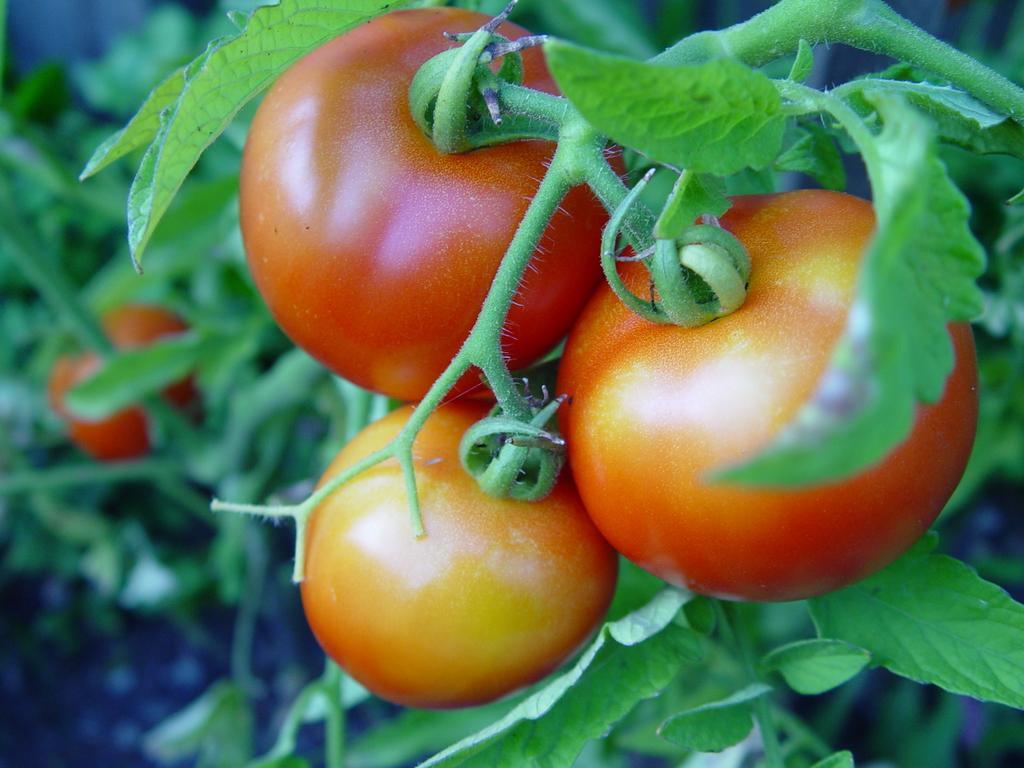How would you summarize this image in a sentence or two? In this image there are tomatoes with leaves. 